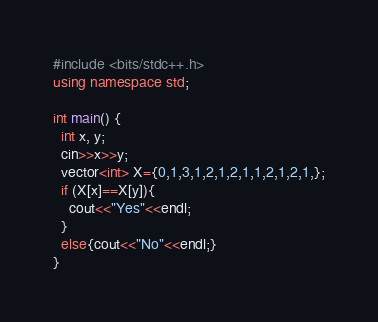Convert code to text. <code><loc_0><loc_0><loc_500><loc_500><_C++_>#include <bits/stdc++.h>
using namespace std;

int main() {
  int x, y;
  cin>>x>>y;
  vector<int> X={0,1,3,1,2,1,2,1,1,2,1,2,1,};
  if (X[x]==X[y]){
    cout<<"Yes"<<endl;
  }
  else{cout<<"No"<<endl;}
}</code> 